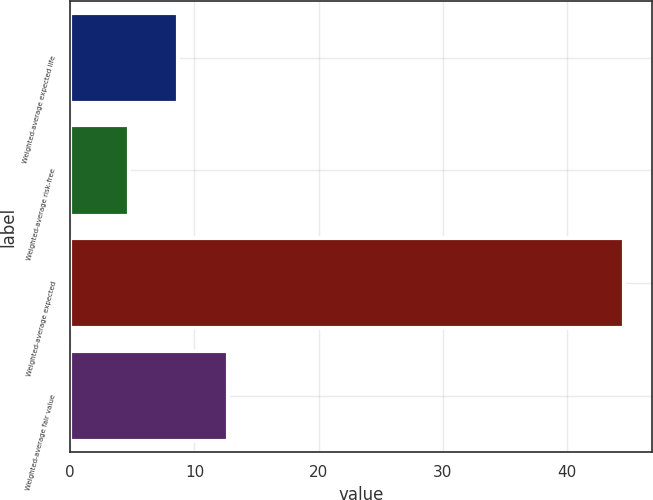<chart> <loc_0><loc_0><loc_500><loc_500><bar_chart><fcel>Weighted-average expected life<fcel>Weighted-average risk-free<fcel>Weighted-average expected<fcel>Weighted-average fair value<nl><fcel>8.69<fcel>4.7<fcel>44.6<fcel>12.68<nl></chart> 